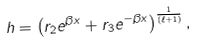Convert formula to latex. <formula><loc_0><loc_0><loc_500><loc_500>h = \left ( r _ { 2 } e ^ { \beta x } + r _ { 3 } e ^ { - \beta x } \right ) ^ { \frac { 1 } { ( \ell + 1 ) } } ,</formula> 